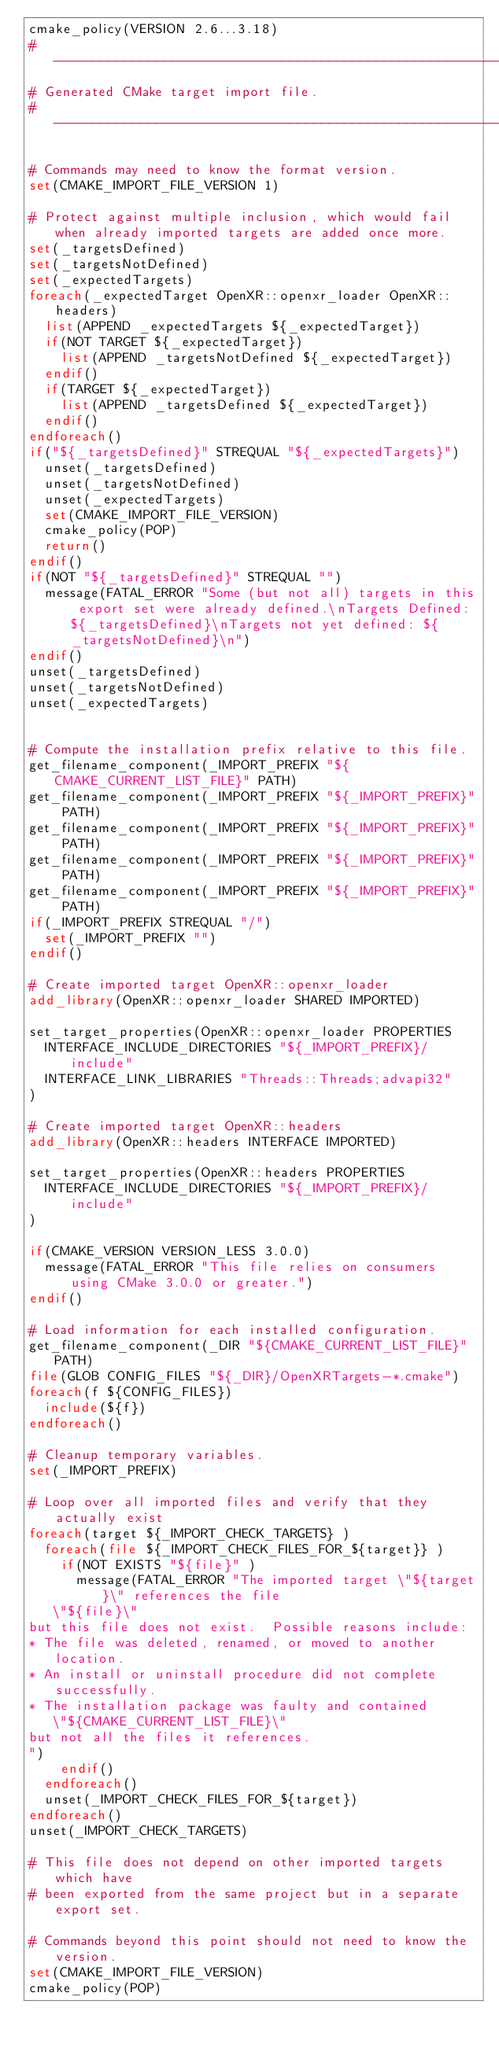<code> <loc_0><loc_0><loc_500><loc_500><_CMake_>cmake_policy(VERSION 2.6...3.18)
#----------------------------------------------------------------
# Generated CMake target import file.
#----------------------------------------------------------------

# Commands may need to know the format version.
set(CMAKE_IMPORT_FILE_VERSION 1)

# Protect against multiple inclusion, which would fail when already imported targets are added once more.
set(_targetsDefined)
set(_targetsNotDefined)
set(_expectedTargets)
foreach(_expectedTarget OpenXR::openxr_loader OpenXR::headers)
  list(APPEND _expectedTargets ${_expectedTarget})
  if(NOT TARGET ${_expectedTarget})
    list(APPEND _targetsNotDefined ${_expectedTarget})
  endif()
  if(TARGET ${_expectedTarget})
    list(APPEND _targetsDefined ${_expectedTarget})
  endif()
endforeach()
if("${_targetsDefined}" STREQUAL "${_expectedTargets}")
  unset(_targetsDefined)
  unset(_targetsNotDefined)
  unset(_expectedTargets)
  set(CMAKE_IMPORT_FILE_VERSION)
  cmake_policy(POP)
  return()
endif()
if(NOT "${_targetsDefined}" STREQUAL "")
  message(FATAL_ERROR "Some (but not all) targets in this export set were already defined.\nTargets Defined: ${_targetsDefined}\nTargets not yet defined: ${_targetsNotDefined}\n")
endif()
unset(_targetsDefined)
unset(_targetsNotDefined)
unset(_expectedTargets)


# Compute the installation prefix relative to this file.
get_filename_component(_IMPORT_PREFIX "${CMAKE_CURRENT_LIST_FILE}" PATH)
get_filename_component(_IMPORT_PREFIX "${_IMPORT_PREFIX}" PATH)
get_filename_component(_IMPORT_PREFIX "${_IMPORT_PREFIX}" PATH)
get_filename_component(_IMPORT_PREFIX "${_IMPORT_PREFIX}" PATH)
get_filename_component(_IMPORT_PREFIX "${_IMPORT_PREFIX}" PATH)
if(_IMPORT_PREFIX STREQUAL "/")
  set(_IMPORT_PREFIX "")
endif()

# Create imported target OpenXR::openxr_loader
add_library(OpenXR::openxr_loader SHARED IMPORTED)

set_target_properties(OpenXR::openxr_loader PROPERTIES
  INTERFACE_INCLUDE_DIRECTORIES "${_IMPORT_PREFIX}/include"
  INTERFACE_LINK_LIBRARIES "Threads::Threads;advapi32"
)

# Create imported target OpenXR::headers
add_library(OpenXR::headers INTERFACE IMPORTED)

set_target_properties(OpenXR::headers PROPERTIES
  INTERFACE_INCLUDE_DIRECTORIES "${_IMPORT_PREFIX}/include"
)

if(CMAKE_VERSION VERSION_LESS 3.0.0)
  message(FATAL_ERROR "This file relies on consumers using CMake 3.0.0 or greater.")
endif()

# Load information for each installed configuration.
get_filename_component(_DIR "${CMAKE_CURRENT_LIST_FILE}" PATH)
file(GLOB CONFIG_FILES "${_DIR}/OpenXRTargets-*.cmake")
foreach(f ${CONFIG_FILES})
  include(${f})
endforeach()

# Cleanup temporary variables.
set(_IMPORT_PREFIX)

# Loop over all imported files and verify that they actually exist
foreach(target ${_IMPORT_CHECK_TARGETS} )
  foreach(file ${_IMPORT_CHECK_FILES_FOR_${target}} )
    if(NOT EXISTS "${file}" )
      message(FATAL_ERROR "The imported target \"${target}\" references the file
   \"${file}\"
but this file does not exist.  Possible reasons include:
* The file was deleted, renamed, or moved to another location.
* An install or uninstall procedure did not complete successfully.
* The installation package was faulty and contained
   \"${CMAKE_CURRENT_LIST_FILE}\"
but not all the files it references.
")
    endif()
  endforeach()
  unset(_IMPORT_CHECK_FILES_FOR_${target})
endforeach()
unset(_IMPORT_CHECK_TARGETS)

# This file does not depend on other imported targets which have
# been exported from the same project but in a separate export set.

# Commands beyond this point should not need to know the version.
set(CMAKE_IMPORT_FILE_VERSION)
cmake_policy(POP)
</code> 